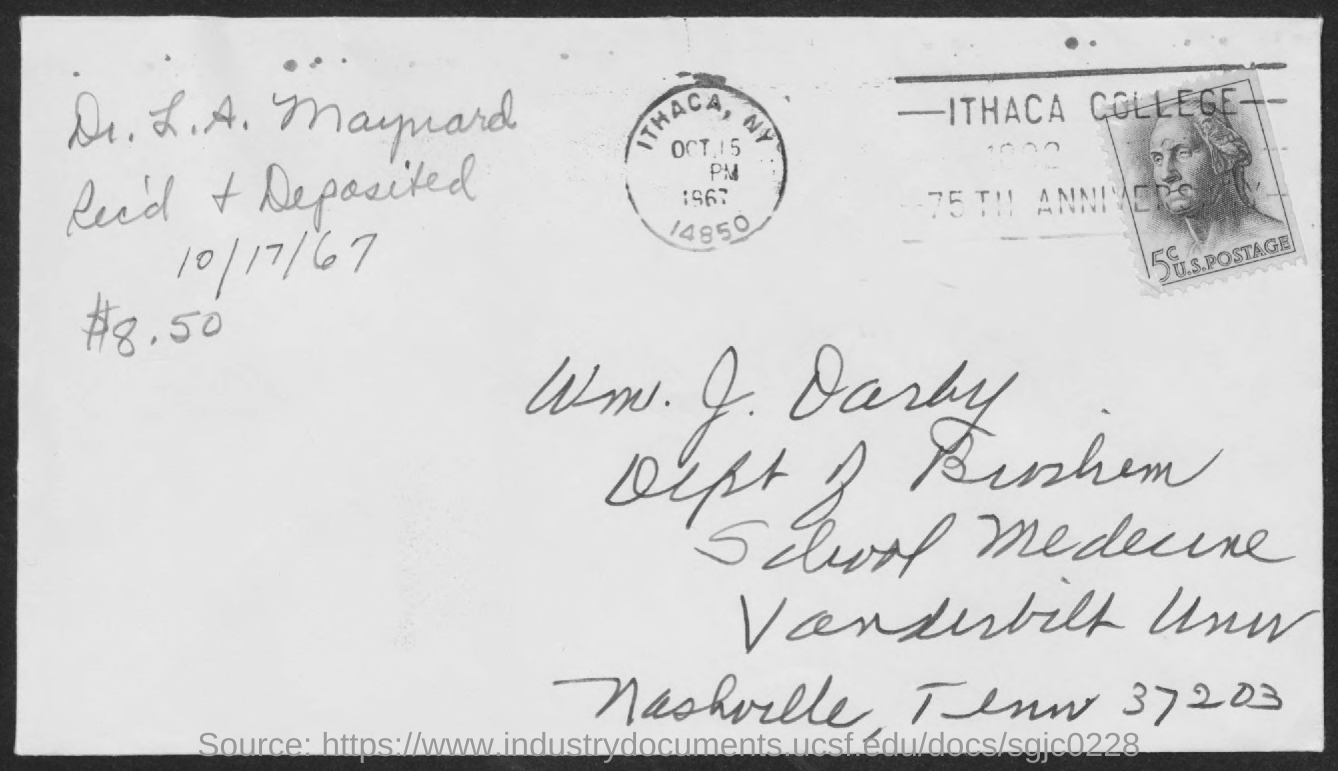Specify some key components in this picture. On October 17, 1967, the item was received and deposited. The postmark indicates that the envelope was mailed from Ithaca, New York. The amount received and deposited was $8.50. 